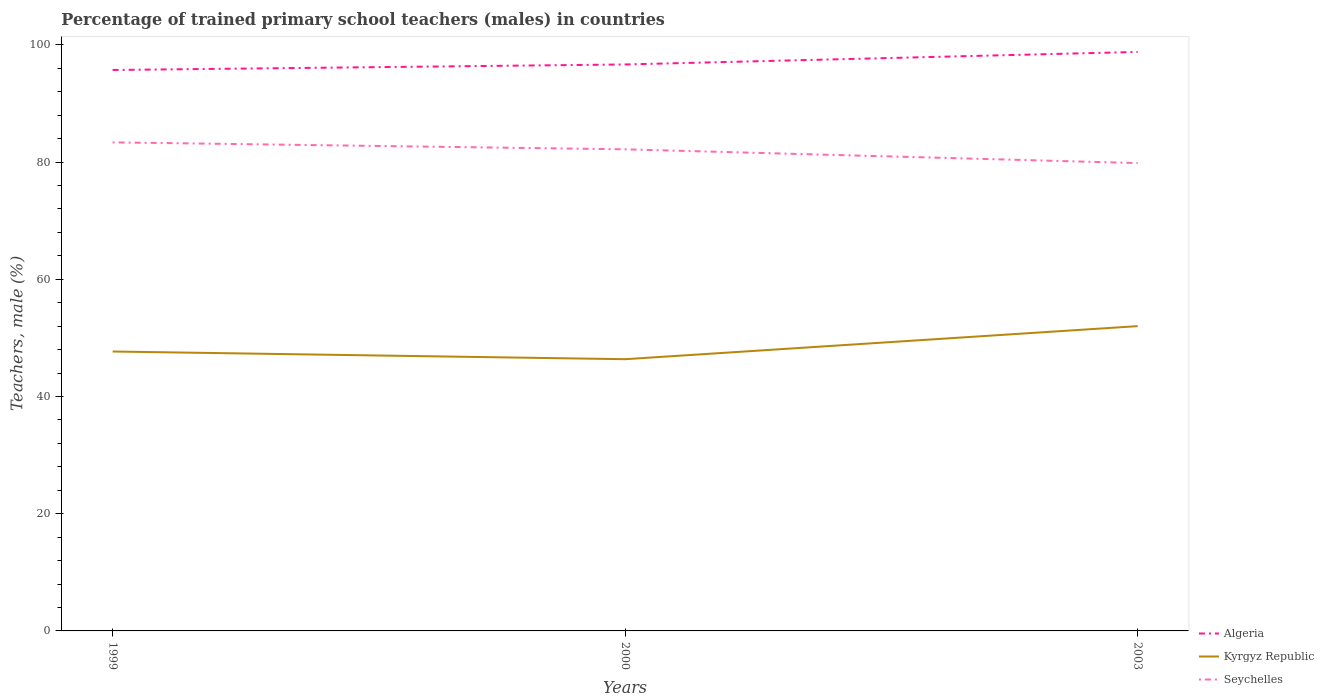Is the number of lines equal to the number of legend labels?
Keep it short and to the point. Yes. Across all years, what is the maximum percentage of trained primary school teachers (males) in Algeria?
Provide a short and direct response. 95.71. What is the total percentage of trained primary school teachers (males) in Seychelles in the graph?
Provide a succinct answer. 3.54. What is the difference between the highest and the second highest percentage of trained primary school teachers (males) in Seychelles?
Provide a succinct answer. 3.54. What is the difference between the highest and the lowest percentage of trained primary school teachers (males) in Kyrgyz Republic?
Provide a short and direct response. 1. How many lines are there?
Provide a succinct answer. 3. What is the difference between two consecutive major ticks on the Y-axis?
Make the answer very short. 20. Does the graph contain grids?
Ensure brevity in your answer.  No. How are the legend labels stacked?
Offer a very short reply. Vertical. What is the title of the graph?
Provide a short and direct response. Percentage of trained primary school teachers (males) in countries. What is the label or title of the Y-axis?
Provide a short and direct response. Teachers, male (%). What is the Teachers, male (%) of Algeria in 1999?
Your answer should be very brief. 95.71. What is the Teachers, male (%) of Kyrgyz Republic in 1999?
Provide a succinct answer. 47.68. What is the Teachers, male (%) of Seychelles in 1999?
Provide a succinct answer. 83.36. What is the Teachers, male (%) of Algeria in 2000?
Your answer should be very brief. 96.65. What is the Teachers, male (%) in Kyrgyz Republic in 2000?
Offer a very short reply. 46.36. What is the Teachers, male (%) in Seychelles in 2000?
Keep it short and to the point. 82.17. What is the Teachers, male (%) in Algeria in 2003?
Offer a terse response. 98.79. What is the Teachers, male (%) in Kyrgyz Republic in 2003?
Make the answer very short. 52.01. What is the Teachers, male (%) in Seychelles in 2003?
Provide a succinct answer. 79.83. Across all years, what is the maximum Teachers, male (%) in Algeria?
Offer a very short reply. 98.79. Across all years, what is the maximum Teachers, male (%) in Kyrgyz Republic?
Keep it short and to the point. 52.01. Across all years, what is the maximum Teachers, male (%) in Seychelles?
Offer a terse response. 83.36. Across all years, what is the minimum Teachers, male (%) of Algeria?
Give a very brief answer. 95.71. Across all years, what is the minimum Teachers, male (%) of Kyrgyz Republic?
Ensure brevity in your answer.  46.36. Across all years, what is the minimum Teachers, male (%) of Seychelles?
Offer a terse response. 79.83. What is the total Teachers, male (%) in Algeria in the graph?
Provide a short and direct response. 291.15. What is the total Teachers, male (%) in Kyrgyz Republic in the graph?
Your answer should be compact. 146.05. What is the total Teachers, male (%) of Seychelles in the graph?
Offer a terse response. 245.36. What is the difference between the Teachers, male (%) in Algeria in 1999 and that in 2000?
Your answer should be very brief. -0.94. What is the difference between the Teachers, male (%) in Kyrgyz Republic in 1999 and that in 2000?
Ensure brevity in your answer.  1.32. What is the difference between the Teachers, male (%) of Seychelles in 1999 and that in 2000?
Make the answer very short. 1.19. What is the difference between the Teachers, male (%) in Algeria in 1999 and that in 2003?
Offer a very short reply. -3.08. What is the difference between the Teachers, male (%) of Kyrgyz Republic in 1999 and that in 2003?
Provide a short and direct response. -4.33. What is the difference between the Teachers, male (%) of Seychelles in 1999 and that in 2003?
Your answer should be compact. 3.54. What is the difference between the Teachers, male (%) in Algeria in 2000 and that in 2003?
Ensure brevity in your answer.  -2.14. What is the difference between the Teachers, male (%) in Kyrgyz Republic in 2000 and that in 2003?
Your response must be concise. -5.64. What is the difference between the Teachers, male (%) of Seychelles in 2000 and that in 2003?
Ensure brevity in your answer.  2.35. What is the difference between the Teachers, male (%) of Algeria in 1999 and the Teachers, male (%) of Kyrgyz Republic in 2000?
Your answer should be compact. 49.35. What is the difference between the Teachers, male (%) in Algeria in 1999 and the Teachers, male (%) in Seychelles in 2000?
Provide a short and direct response. 13.54. What is the difference between the Teachers, male (%) in Kyrgyz Republic in 1999 and the Teachers, male (%) in Seychelles in 2000?
Your answer should be very brief. -34.5. What is the difference between the Teachers, male (%) in Algeria in 1999 and the Teachers, male (%) in Kyrgyz Republic in 2003?
Ensure brevity in your answer.  43.7. What is the difference between the Teachers, male (%) in Algeria in 1999 and the Teachers, male (%) in Seychelles in 2003?
Your answer should be compact. 15.88. What is the difference between the Teachers, male (%) in Kyrgyz Republic in 1999 and the Teachers, male (%) in Seychelles in 2003?
Make the answer very short. -32.15. What is the difference between the Teachers, male (%) in Algeria in 2000 and the Teachers, male (%) in Kyrgyz Republic in 2003?
Give a very brief answer. 44.65. What is the difference between the Teachers, male (%) of Algeria in 2000 and the Teachers, male (%) of Seychelles in 2003?
Provide a succinct answer. 16.83. What is the difference between the Teachers, male (%) in Kyrgyz Republic in 2000 and the Teachers, male (%) in Seychelles in 2003?
Give a very brief answer. -33.46. What is the average Teachers, male (%) of Algeria per year?
Your response must be concise. 97.05. What is the average Teachers, male (%) of Kyrgyz Republic per year?
Your answer should be compact. 48.68. What is the average Teachers, male (%) in Seychelles per year?
Your answer should be very brief. 81.79. In the year 1999, what is the difference between the Teachers, male (%) in Algeria and Teachers, male (%) in Kyrgyz Republic?
Offer a very short reply. 48.03. In the year 1999, what is the difference between the Teachers, male (%) in Algeria and Teachers, male (%) in Seychelles?
Your answer should be very brief. 12.35. In the year 1999, what is the difference between the Teachers, male (%) in Kyrgyz Republic and Teachers, male (%) in Seychelles?
Offer a terse response. -35.68. In the year 2000, what is the difference between the Teachers, male (%) of Algeria and Teachers, male (%) of Kyrgyz Republic?
Keep it short and to the point. 50.29. In the year 2000, what is the difference between the Teachers, male (%) of Algeria and Teachers, male (%) of Seychelles?
Keep it short and to the point. 14.48. In the year 2000, what is the difference between the Teachers, male (%) of Kyrgyz Republic and Teachers, male (%) of Seychelles?
Provide a succinct answer. -35.81. In the year 2003, what is the difference between the Teachers, male (%) in Algeria and Teachers, male (%) in Kyrgyz Republic?
Offer a terse response. 46.78. In the year 2003, what is the difference between the Teachers, male (%) of Algeria and Teachers, male (%) of Seychelles?
Make the answer very short. 18.96. In the year 2003, what is the difference between the Teachers, male (%) of Kyrgyz Republic and Teachers, male (%) of Seychelles?
Your answer should be compact. -27.82. What is the ratio of the Teachers, male (%) of Algeria in 1999 to that in 2000?
Offer a very short reply. 0.99. What is the ratio of the Teachers, male (%) in Kyrgyz Republic in 1999 to that in 2000?
Your answer should be compact. 1.03. What is the ratio of the Teachers, male (%) of Seychelles in 1999 to that in 2000?
Give a very brief answer. 1.01. What is the ratio of the Teachers, male (%) in Algeria in 1999 to that in 2003?
Your response must be concise. 0.97. What is the ratio of the Teachers, male (%) in Kyrgyz Republic in 1999 to that in 2003?
Keep it short and to the point. 0.92. What is the ratio of the Teachers, male (%) in Seychelles in 1999 to that in 2003?
Your answer should be compact. 1.04. What is the ratio of the Teachers, male (%) of Algeria in 2000 to that in 2003?
Keep it short and to the point. 0.98. What is the ratio of the Teachers, male (%) in Kyrgyz Republic in 2000 to that in 2003?
Give a very brief answer. 0.89. What is the ratio of the Teachers, male (%) of Seychelles in 2000 to that in 2003?
Your answer should be compact. 1.03. What is the difference between the highest and the second highest Teachers, male (%) of Algeria?
Provide a short and direct response. 2.14. What is the difference between the highest and the second highest Teachers, male (%) of Kyrgyz Republic?
Your answer should be very brief. 4.33. What is the difference between the highest and the second highest Teachers, male (%) of Seychelles?
Provide a short and direct response. 1.19. What is the difference between the highest and the lowest Teachers, male (%) in Algeria?
Provide a succinct answer. 3.08. What is the difference between the highest and the lowest Teachers, male (%) in Kyrgyz Republic?
Give a very brief answer. 5.64. What is the difference between the highest and the lowest Teachers, male (%) in Seychelles?
Your answer should be compact. 3.54. 